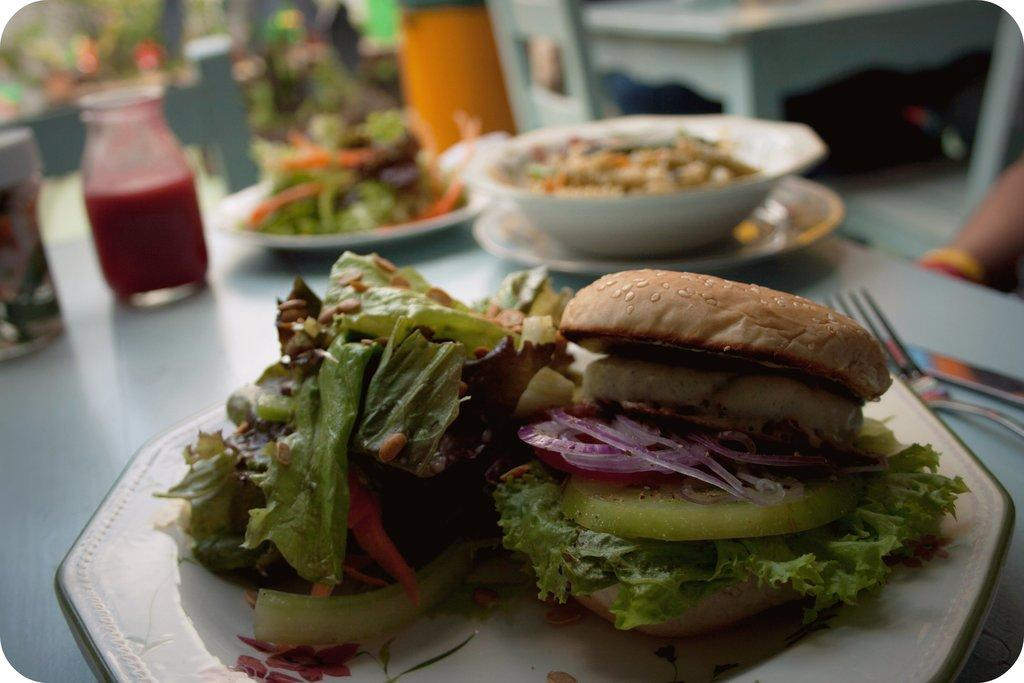What can be found on the table in the image? There are food items, plates, forks, and bowls on the table in the image. What else is visible on the table? There are jars visible on the table. Can you describe the table in the image? There is a table in the image, and it has various items placed on it. What is the condition of the background in the image? The background of the image is blurry. Is there any indication of a person's presence in the image? Yes, a person's hand is visible on the right side of the image. What is the price of the bath in the image? There is no bath present in the image, so it is not possible to determine the price. 